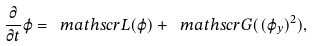Convert formula to latex. <formula><loc_0><loc_0><loc_500><loc_500>\frac { \partial } { \partial t } \varphi = { \ m a t h s c r L } ( \varphi ) + { \ m a t h s c r G } ( ( \varphi _ { y } ) ^ { 2 } ) ,</formula> 